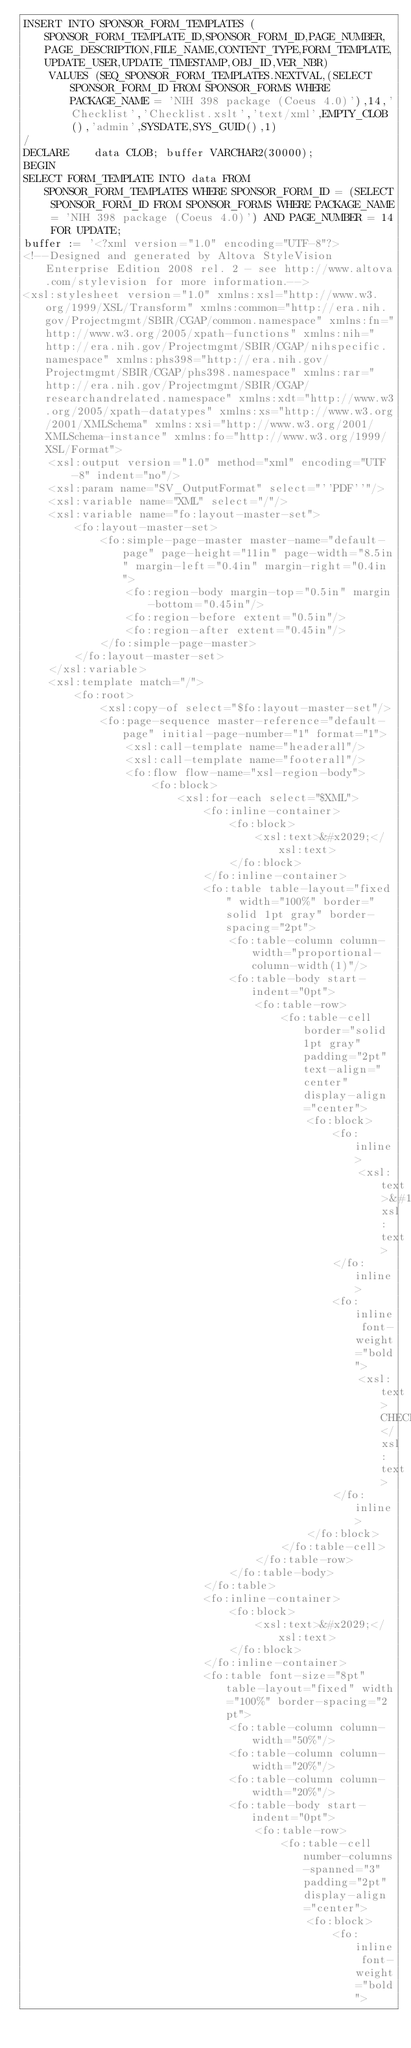Convert code to text. <code><loc_0><loc_0><loc_500><loc_500><_SQL_>INSERT INTO SPONSOR_FORM_TEMPLATES (SPONSOR_FORM_TEMPLATE_ID,SPONSOR_FORM_ID,PAGE_NUMBER,PAGE_DESCRIPTION,FILE_NAME,CONTENT_TYPE,FORM_TEMPLATE,UPDATE_USER,UPDATE_TIMESTAMP,OBJ_ID,VER_NBR) 
    VALUES (SEQ_SPONSOR_FORM_TEMPLATES.NEXTVAL,(SELECT SPONSOR_FORM_ID FROM SPONSOR_FORMS WHERE PACKAGE_NAME = 'NIH 398 package (Coeus 4.0)'),14,'Checklist','Checklist.xslt','text/xml',EMPTY_CLOB(),'admin',SYSDATE,SYS_GUID(),1)
/
DECLARE    data CLOB; buffer VARCHAR2(30000);
BEGIN
SELECT FORM_TEMPLATE INTO data FROM SPONSOR_FORM_TEMPLATES WHERE SPONSOR_FORM_ID = (SELECT SPONSOR_FORM_ID FROM SPONSOR_FORMS WHERE PACKAGE_NAME = 'NIH 398 package (Coeus 4.0)') AND PAGE_NUMBER = 14 FOR UPDATE;
buffer := '<?xml version="1.0" encoding="UTF-8"?>
<!--Designed and generated by Altova StyleVision Enterprise Edition 2008 rel. 2 - see http://www.altova.com/stylevision for more information.-->
<xsl:stylesheet version="1.0" xmlns:xsl="http://www.w3.org/1999/XSL/Transform" xmlns:common="http://era.nih.gov/Projectmgmt/SBIR/CGAP/common.namespace" xmlns:fn="http://www.w3.org/2005/xpath-functions" xmlns:nih="http://era.nih.gov/Projectmgmt/SBIR/CGAP/nihspecific.namespace" xmlns:phs398="http://era.nih.gov/Projectmgmt/SBIR/CGAP/phs398.namespace" xmlns:rar="http://era.nih.gov/Projectmgmt/SBIR/CGAP/researchandrelated.namespace" xmlns:xdt="http://www.w3.org/2005/xpath-datatypes" xmlns:xs="http://www.w3.org/2001/XMLSchema" xmlns:xsi="http://www.w3.org/2001/XMLSchema-instance" xmlns:fo="http://www.w3.org/1999/XSL/Format">
    <xsl:output version="1.0" method="xml" encoding="UTF-8" indent="no"/>
    <xsl:param name="SV_OutputFormat" select="''PDF''"/>
    <xsl:variable name="XML" select="/"/>
    <xsl:variable name="fo:layout-master-set">
        <fo:layout-master-set>
            <fo:simple-page-master master-name="default-page" page-height="11in" page-width="8.5in" margin-left="0.4in" margin-right="0.4in">
                <fo:region-body margin-top="0.5in" margin-bottom="0.45in"/>
                <fo:region-before extent="0.5in"/>
                <fo:region-after extent="0.45in"/>
            </fo:simple-page-master>
        </fo:layout-master-set>
    </xsl:variable>
    <xsl:template match="/">
        <fo:root>
            <xsl:copy-of select="$fo:layout-master-set"/>
            <fo:page-sequence master-reference="default-page" initial-page-number="1" format="1">
                <xsl:call-template name="headerall"/>
                <xsl:call-template name="footerall"/>
                <fo:flow flow-name="xsl-region-body">
                    <fo:block>
                        <xsl:for-each select="$XML">
                            <fo:inline-container>
                                <fo:block>
                                    <xsl:text>&#x2029;</xsl:text>
                                </fo:block>
                            </fo:inline-container>
                            <fo:table table-layout="fixed" width="100%" border="solid 1pt gray" border-spacing="2pt">
                                <fo:table-column column-width="proportional-column-width(1)"/>
                                <fo:table-body start-indent="0pt">
                                    <fo:table-row>
                                        <fo:table-cell border="solid 1pt gray" padding="2pt" text-align="center" display-align="center">
                                            <fo:block>
                                                <fo:inline>
                                                    <xsl:text>&#160;</xsl:text>
                                                </fo:inline>
                                                <fo:inline font-weight="bold">
                                                    <xsl:text>CHECKLIST</xsl:text>
                                                </fo:inline>
                                            </fo:block>
                                        </fo:table-cell>
                                    </fo:table-row>
                                </fo:table-body>
                            </fo:table>
                            <fo:inline-container>
                                <fo:block>
                                    <xsl:text>&#x2029;</xsl:text>
                                </fo:block>
                            </fo:inline-container>
                            <fo:table font-size="8pt" table-layout="fixed" width="100%" border-spacing="2pt">
                                <fo:table-column column-width="50%"/>
                                <fo:table-column column-width="20%"/>
                                <fo:table-column column-width="20%"/>
                                <fo:table-body start-indent="0pt">
                                    <fo:table-row>
                                        <fo:table-cell number-columns-spanned="3" padding="2pt" display-align="center">
                                            <fo:block>
                                                <fo:inline font-weight="bold"></code> 